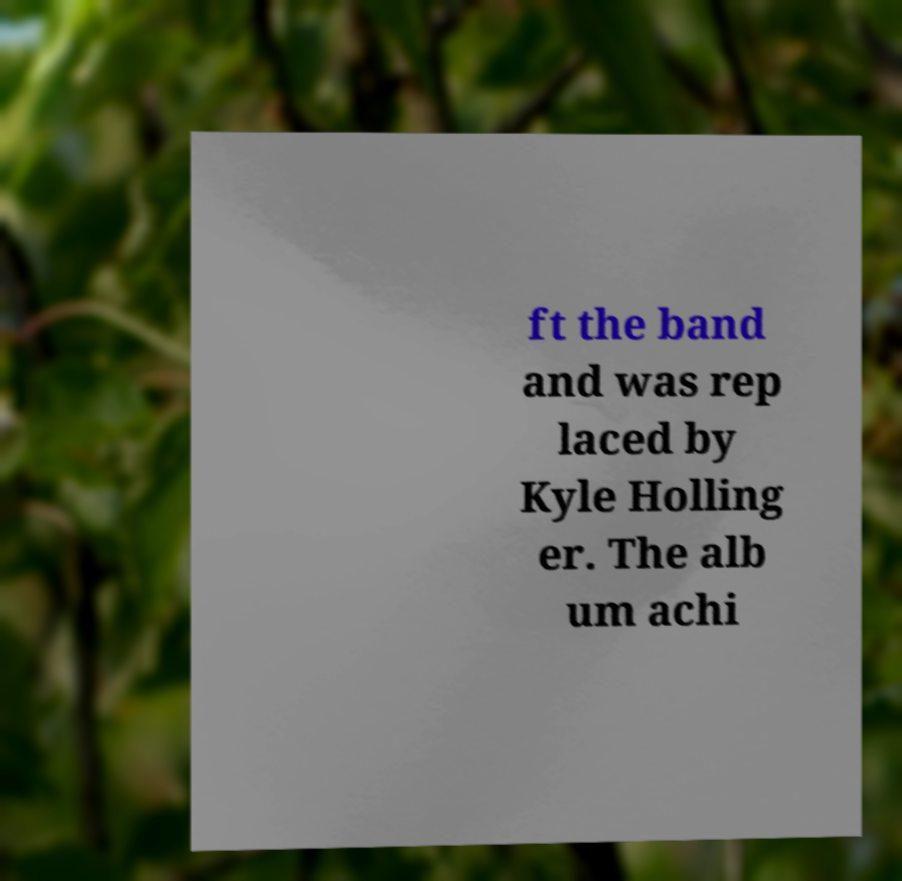I need the written content from this picture converted into text. Can you do that? ft the band and was rep laced by Kyle Holling er. The alb um achi 